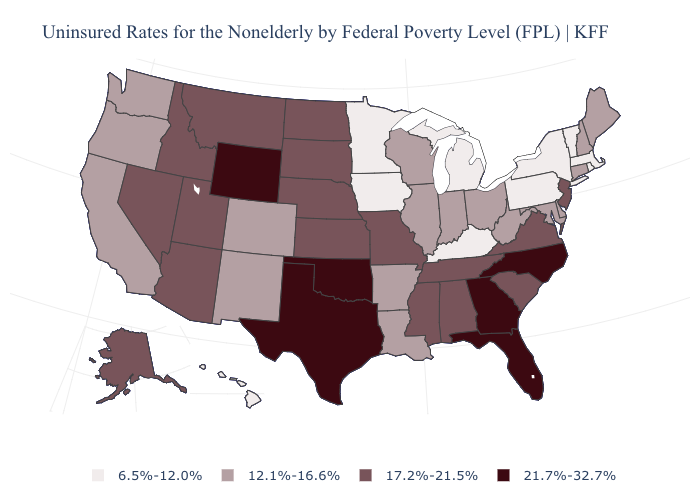What is the value of Maryland?
Answer briefly. 12.1%-16.6%. Name the states that have a value in the range 17.2%-21.5%?
Give a very brief answer. Alabama, Alaska, Arizona, Idaho, Kansas, Mississippi, Missouri, Montana, Nebraska, Nevada, New Jersey, North Dakota, South Carolina, South Dakota, Tennessee, Utah, Virginia. Does Arizona have a lower value than Maine?
Give a very brief answer. No. Name the states that have a value in the range 6.5%-12.0%?
Write a very short answer. Hawaii, Iowa, Kentucky, Massachusetts, Michigan, Minnesota, New York, Pennsylvania, Rhode Island, Vermont. Name the states that have a value in the range 12.1%-16.6%?
Be succinct. Arkansas, California, Colorado, Connecticut, Delaware, Illinois, Indiana, Louisiana, Maine, Maryland, New Hampshire, New Mexico, Ohio, Oregon, Washington, West Virginia, Wisconsin. What is the lowest value in the USA?
Answer briefly. 6.5%-12.0%. Name the states that have a value in the range 21.7%-32.7%?
Be succinct. Florida, Georgia, North Carolina, Oklahoma, Texas, Wyoming. Which states have the lowest value in the USA?
Answer briefly. Hawaii, Iowa, Kentucky, Massachusetts, Michigan, Minnesota, New York, Pennsylvania, Rhode Island, Vermont. Name the states that have a value in the range 21.7%-32.7%?
Short answer required. Florida, Georgia, North Carolina, Oklahoma, Texas, Wyoming. What is the lowest value in the USA?
Short answer required. 6.5%-12.0%. Name the states that have a value in the range 6.5%-12.0%?
Keep it brief. Hawaii, Iowa, Kentucky, Massachusetts, Michigan, Minnesota, New York, Pennsylvania, Rhode Island, Vermont. Does Texas have a lower value than Colorado?
Write a very short answer. No. Does Connecticut have a higher value than Alabama?
Keep it brief. No. Among the states that border Rhode Island , which have the highest value?
Keep it brief. Connecticut. Does Utah have the same value as New Jersey?
Short answer required. Yes. 